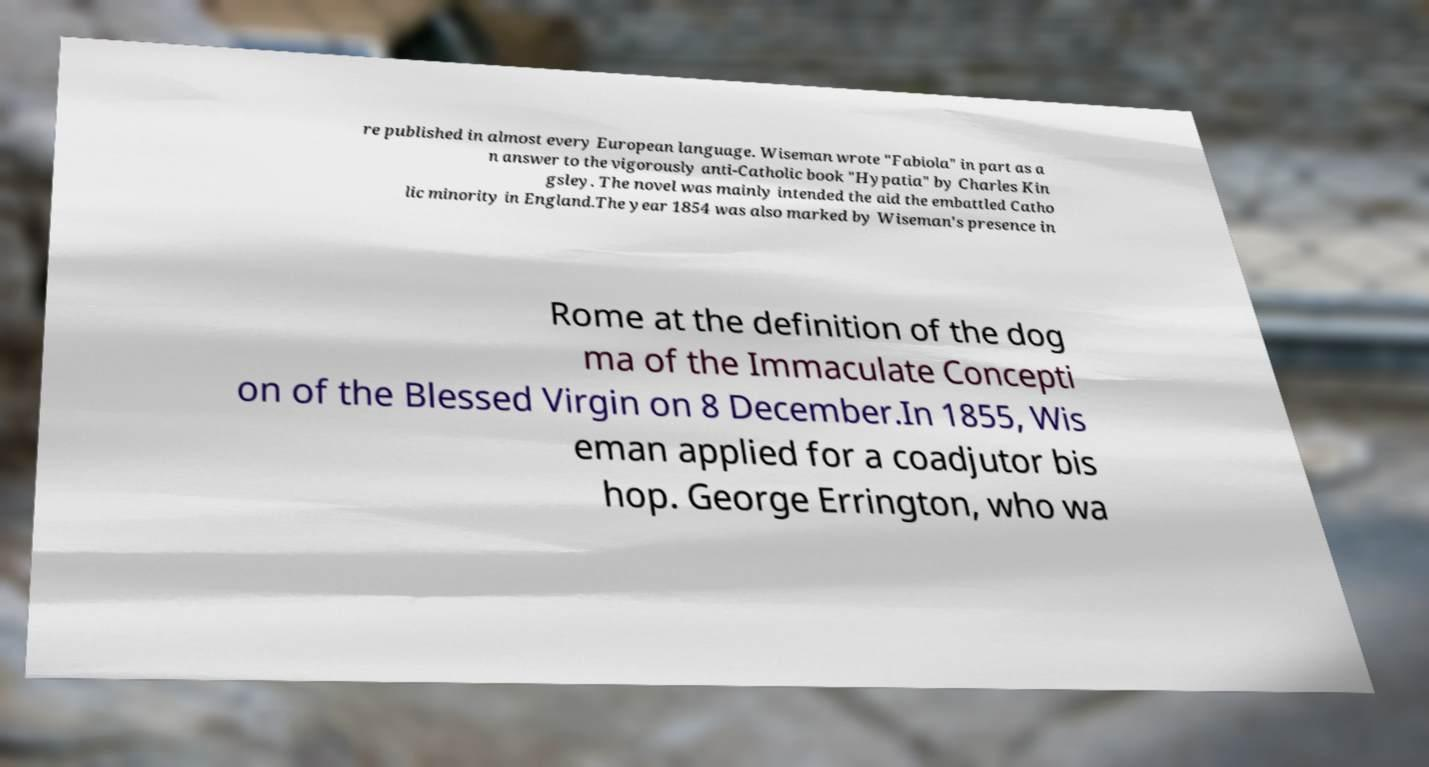Could you extract and type out the text from this image? re published in almost every European language. Wiseman wrote "Fabiola" in part as a n answer to the vigorously anti-Catholic book "Hypatia" by Charles Kin gsley. The novel was mainly intended the aid the embattled Catho lic minority in England.The year 1854 was also marked by Wiseman's presence in Rome at the definition of the dog ma of the Immaculate Concepti on of the Blessed Virgin on 8 December.In 1855, Wis eman applied for a coadjutor bis hop. George Errington, who wa 